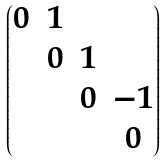<formula> <loc_0><loc_0><loc_500><loc_500>\begin{pmatrix} 0 & 1 & & \\ & 0 & 1 & \\ & & 0 & - 1 \\ & & & 0 \end{pmatrix}</formula> 